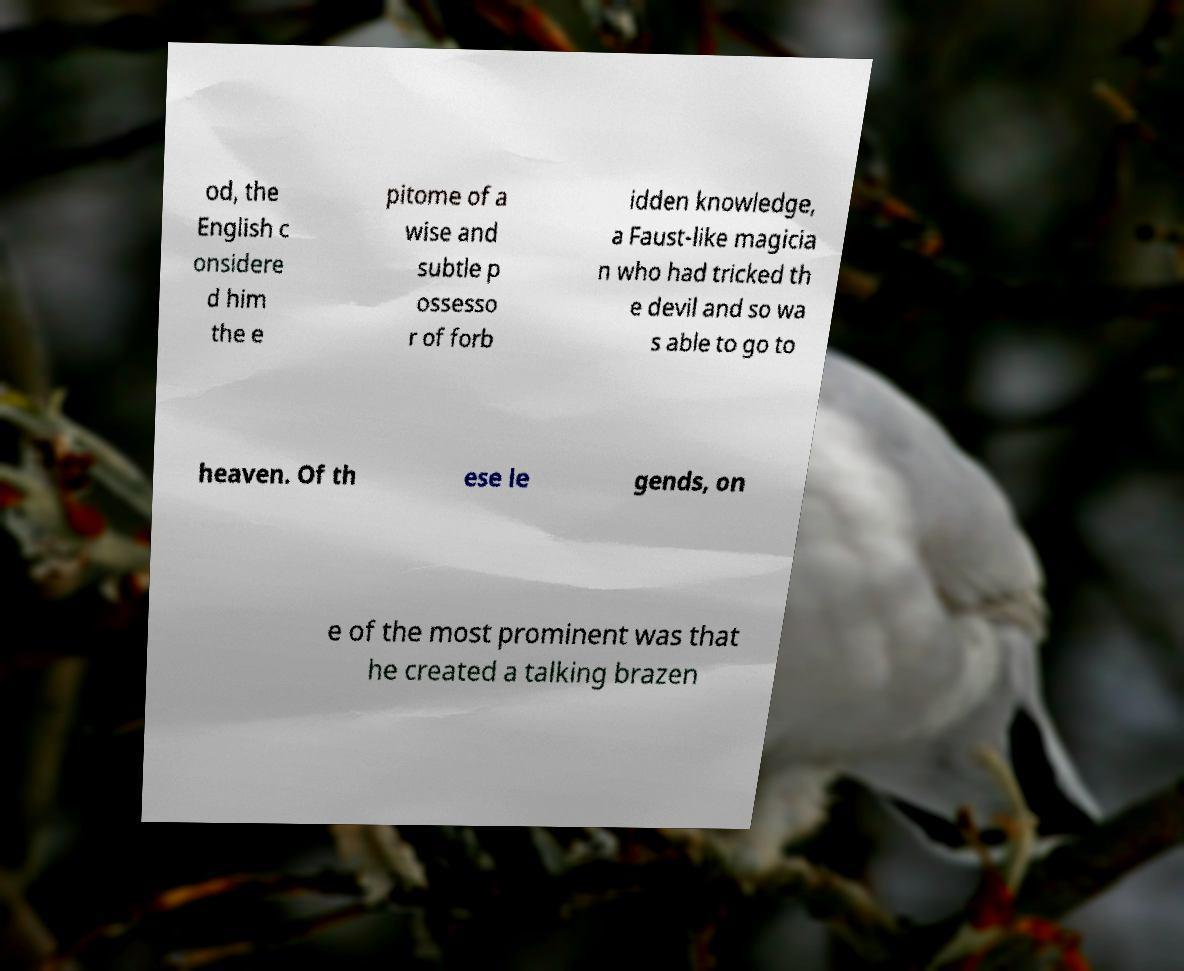I need the written content from this picture converted into text. Can you do that? od, the English c onsidere d him the e pitome of a wise and subtle p ossesso r of forb idden knowledge, a Faust-like magicia n who had tricked th e devil and so wa s able to go to heaven. Of th ese le gends, on e of the most prominent was that he created a talking brazen 